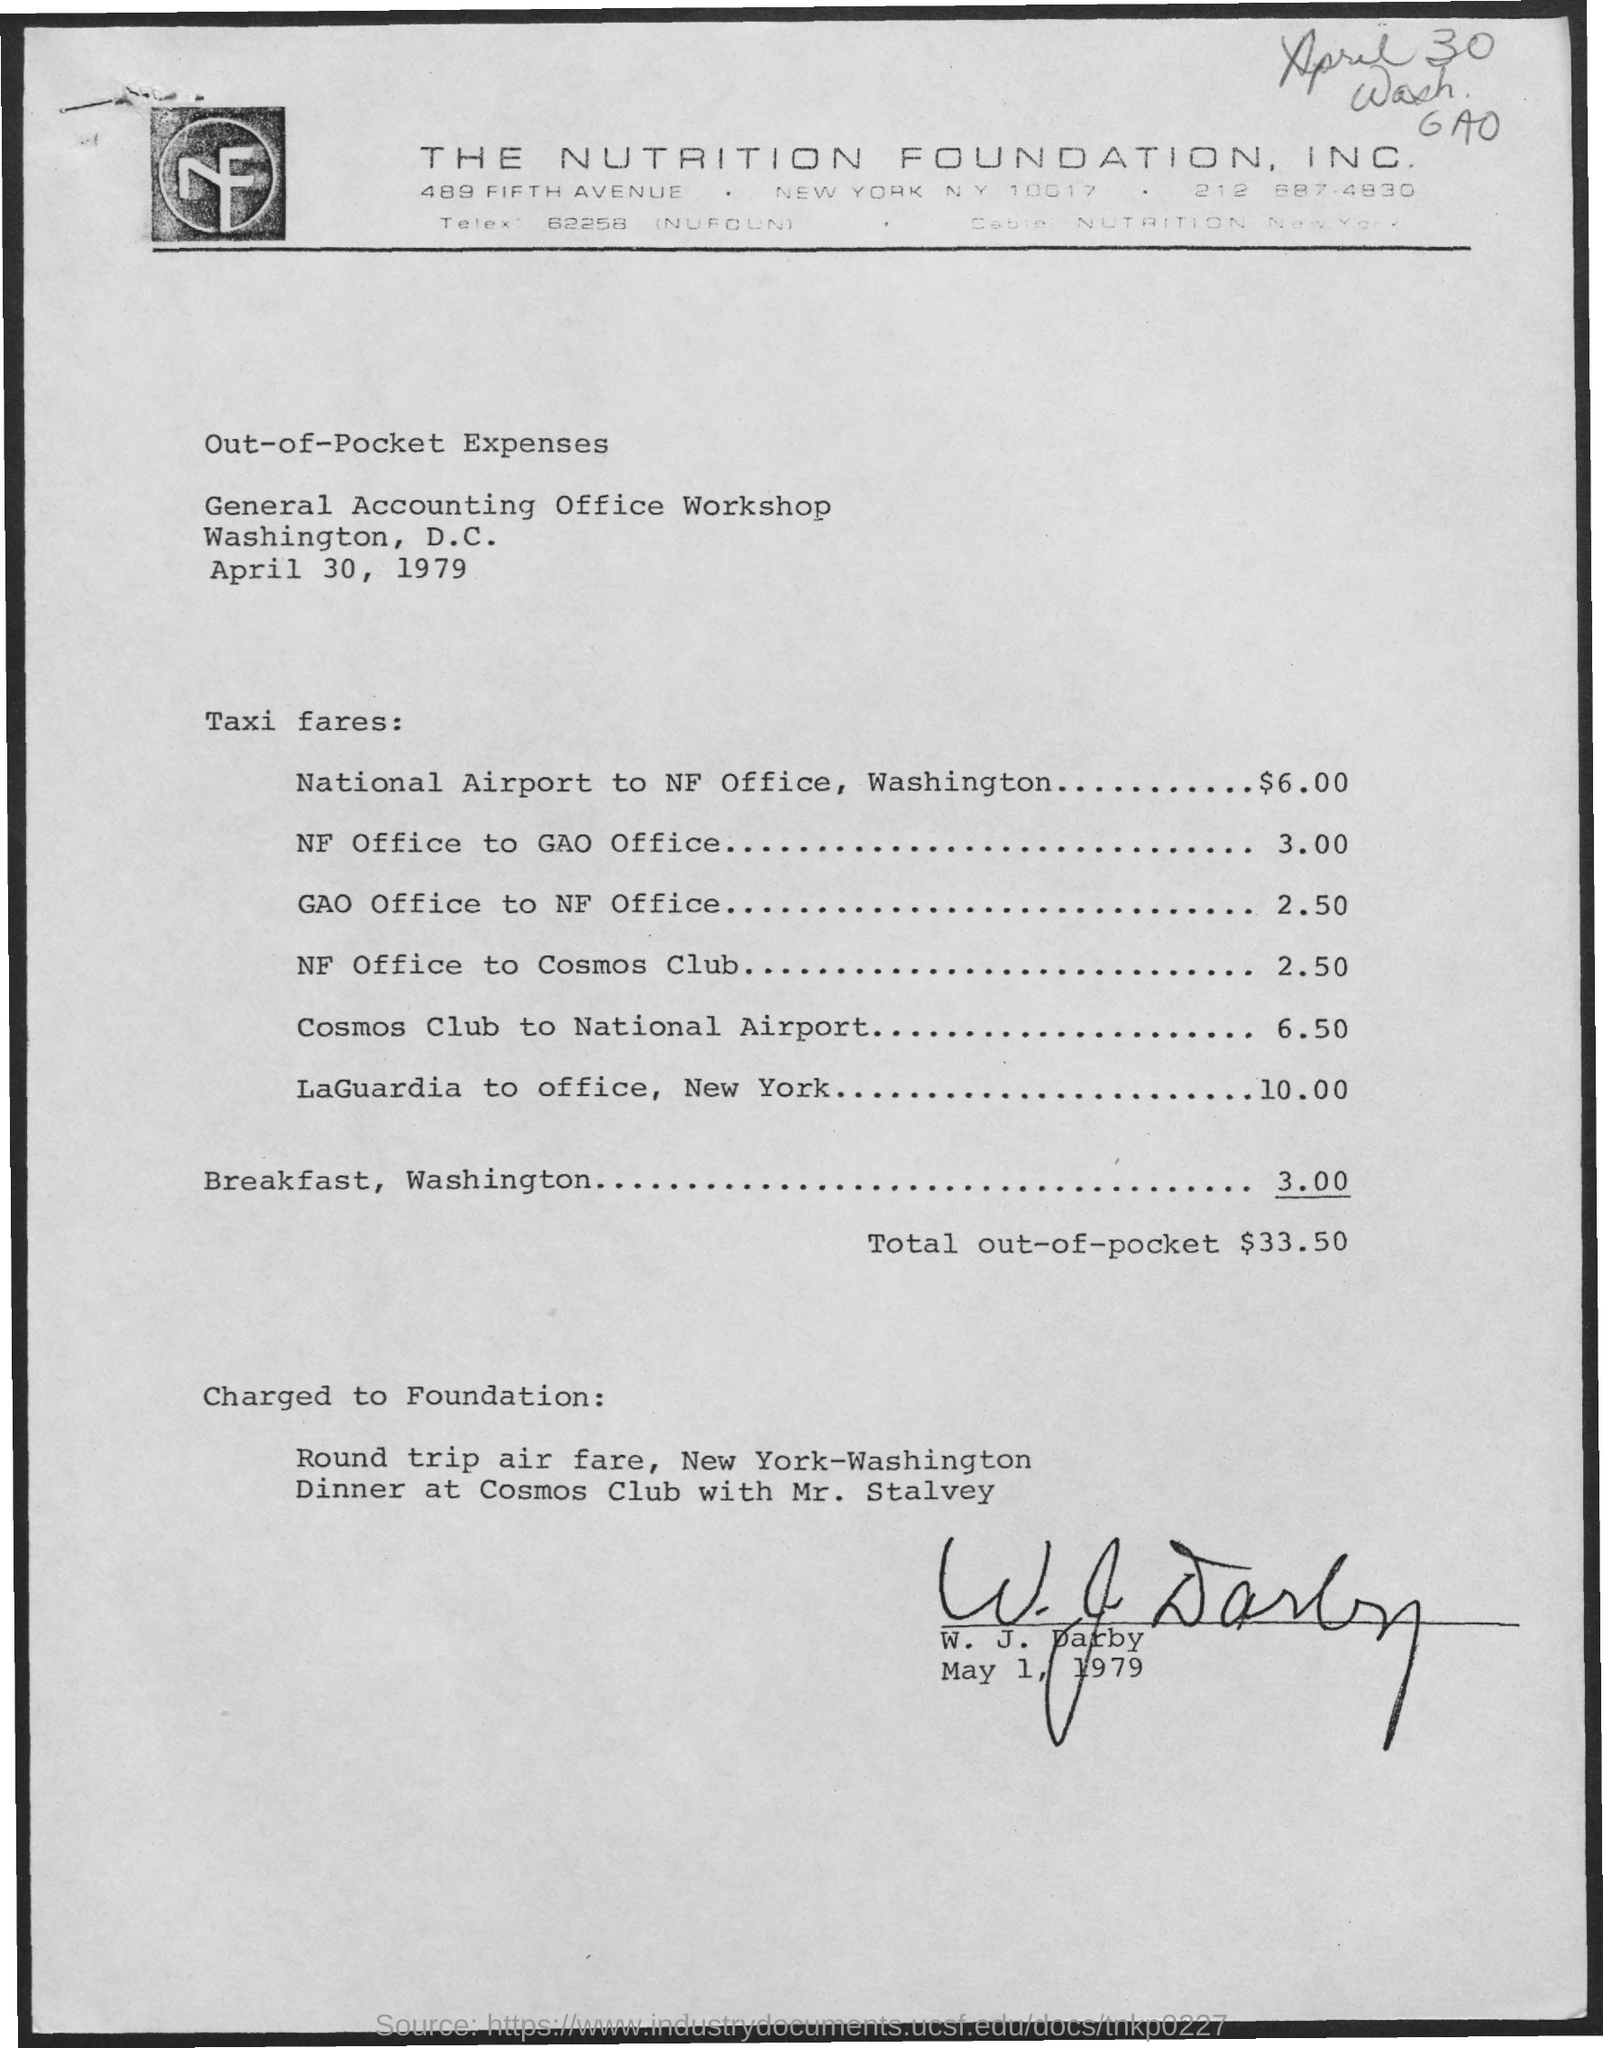Indicate a few pertinent items in this graphic. The amount spent on breakfast in Washington is 3.00. The total out-of-pocket amount is $33.50. The taxi fare from the National Airport in Washington to the National Park Service office is $6.00. The letterhead belongs to The Nutrition Foundation, Inc. 